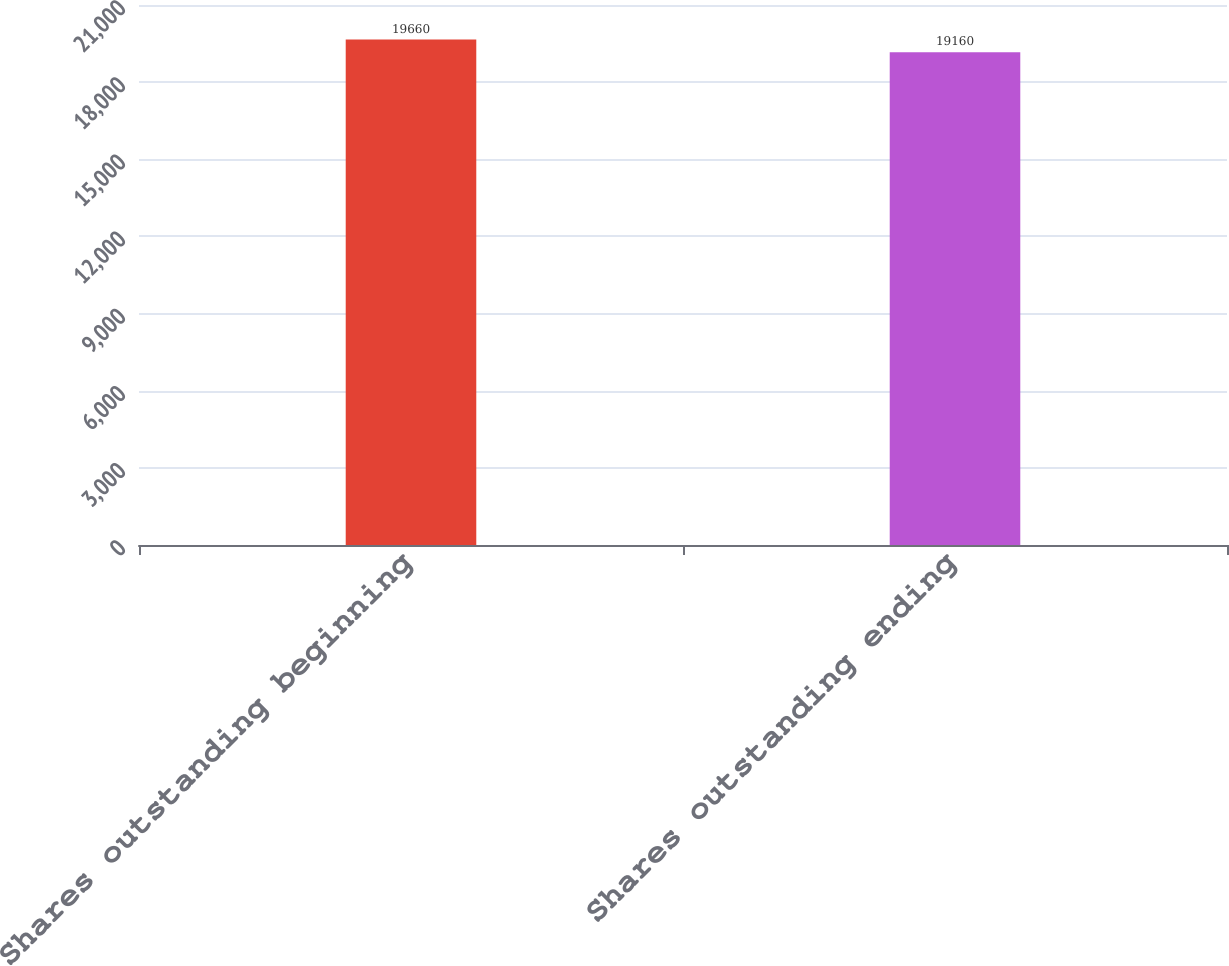Convert chart. <chart><loc_0><loc_0><loc_500><loc_500><bar_chart><fcel>Shares outstanding beginning<fcel>Shares outstanding ending<nl><fcel>19660<fcel>19160<nl></chart> 